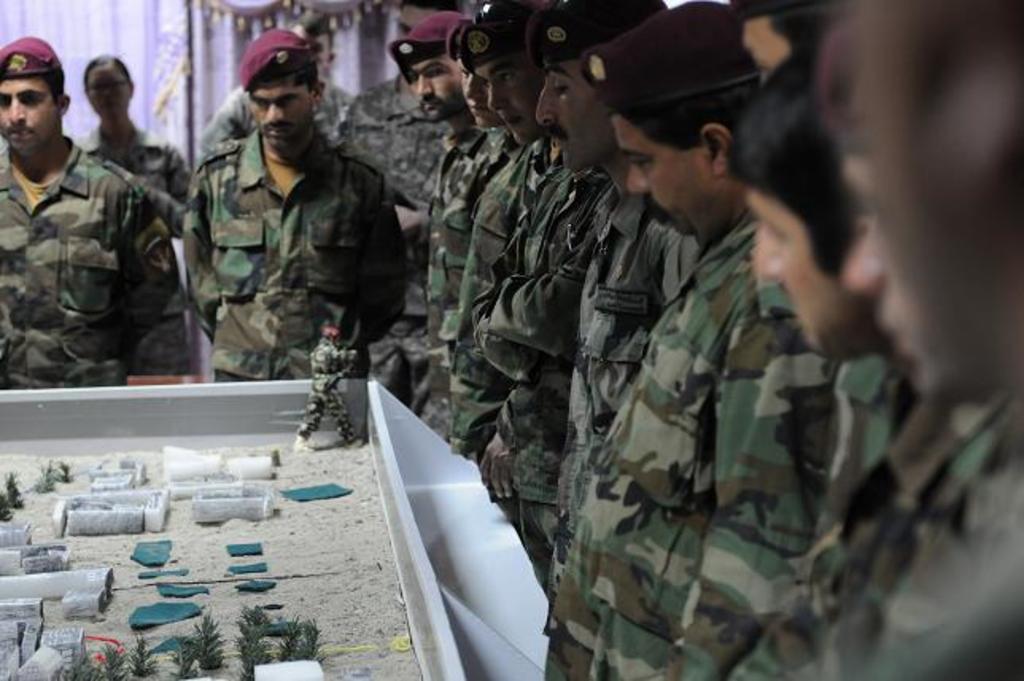In one or two sentences, can you explain what this image depicts? This picture describes about group of people, they are standing and few people wore caps, in front of them we can see a miniature. 